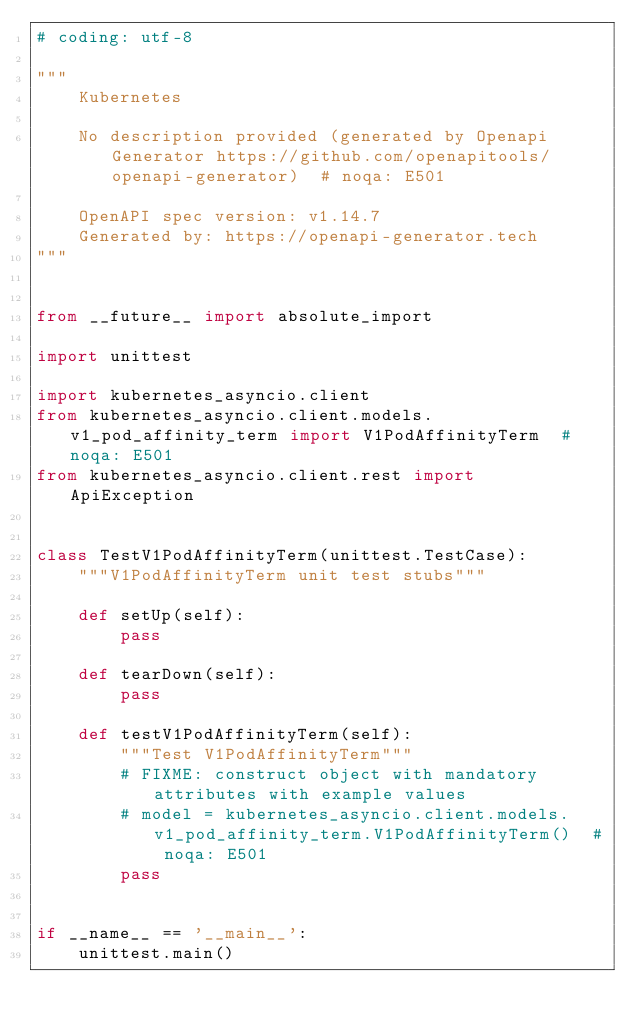Convert code to text. <code><loc_0><loc_0><loc_500><loc_500><_Python_># coding: utf-8

"""
    Kubernetes

    No description provided (generated by Openapi Generator https://github.com/openapitools/openapi-generator)  # noqa: E501

    OpenAPI spec version: v1.14.7
    Generated by: https://openapi-generator.tech
"""


from __future__ import absolute_import

import unittest

import kubernetes_asyncio.client
from kubernetes_asyncio.client.models.v1_pod_affinity_term import V1PodAffinityTerm  # noqa: E501
from kubernetes_asyncio.client.rest import ApiException


class TestV1PodAffinityTerm(unittest.TestCase):
    """V1PodAffinityTerm unit test stubs"""

    def setUp(self):
        pass

    def tearDown(self):
        pass

    def testV1PodAffinityTerm(self):
        """Test V1PodAffinityTerm"""
        # FIXME: construct object with mandatory attributes with example values
        # model = kubernetes_asyncio.client.models.v1_pod_affinity_term.V1PodAffinityTerm()  # noqa: E501
        pass


if __name__ == '__main__':
    unittest.main()
</code> 